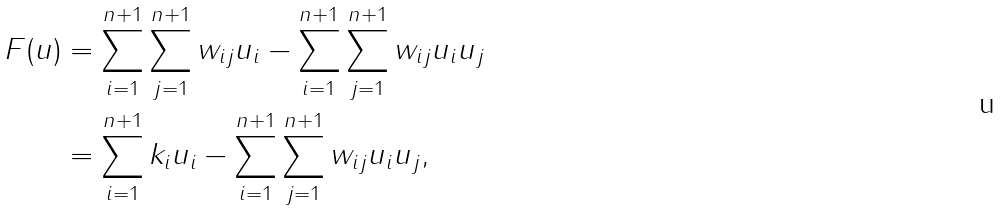<formula> <loc_0><loc_0><loc_500><loc_500>F ( u ) & = \sum _ { i = 1 } ^ { n + 1 } \sum _ { j = 1 } ^ { n + 1 } w _ { i j } u _ { i } - \sum _ { i = 1 } ^ { n + 1 } \sum _ { j = 1 } ^ { n + 1 } w _ { i j } u _ { i } u _ { j } \\ & = \sum _ { i = 1 } ^ { n + 1 } k _ { i } u _ { i } - \sum _ { i = 1 } ^ { n + 1 } \sum _ { j = 1 } ^ { n + 1 } w _ { i j } u _ { i } u _ { j } ,</formula> 